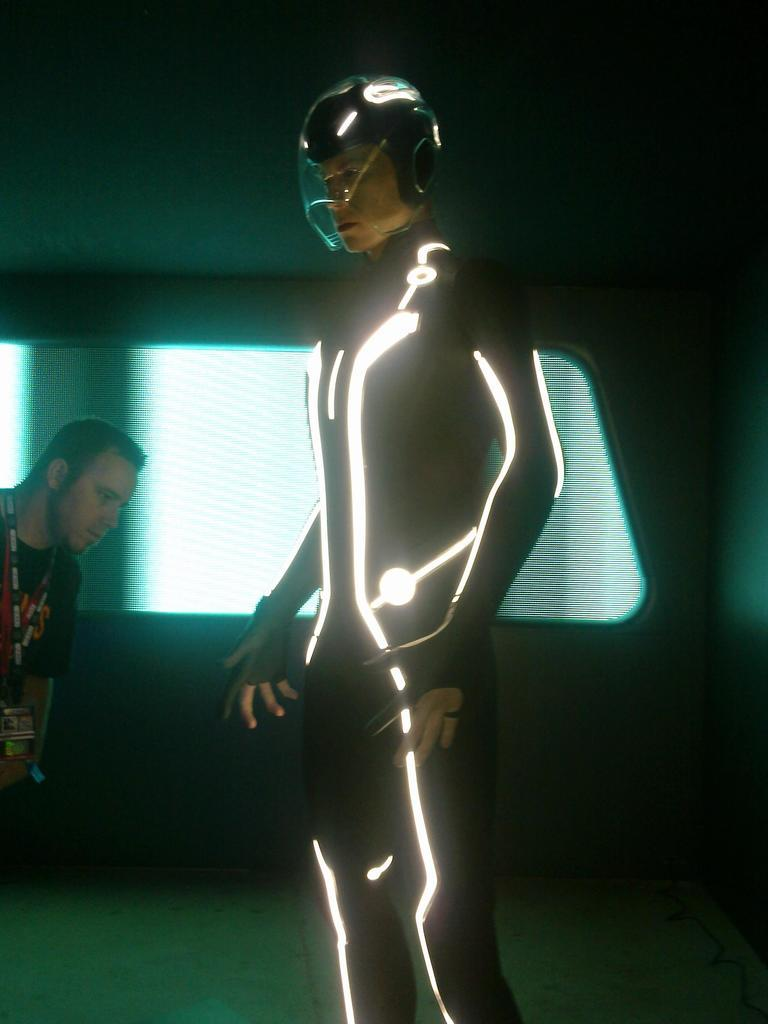What is the person in the image wearing? The person in the image is wearing a fancy dress. Can you describe the man on the left side of the person? There is a man on the left side of the person in the image. What is visible behind the people in the image? There is a wall behind the people in the image. What type of seed can be seen growing on the wall in the image? There is no seed growing on the wall in the image; only the wall is visible behind the people. 